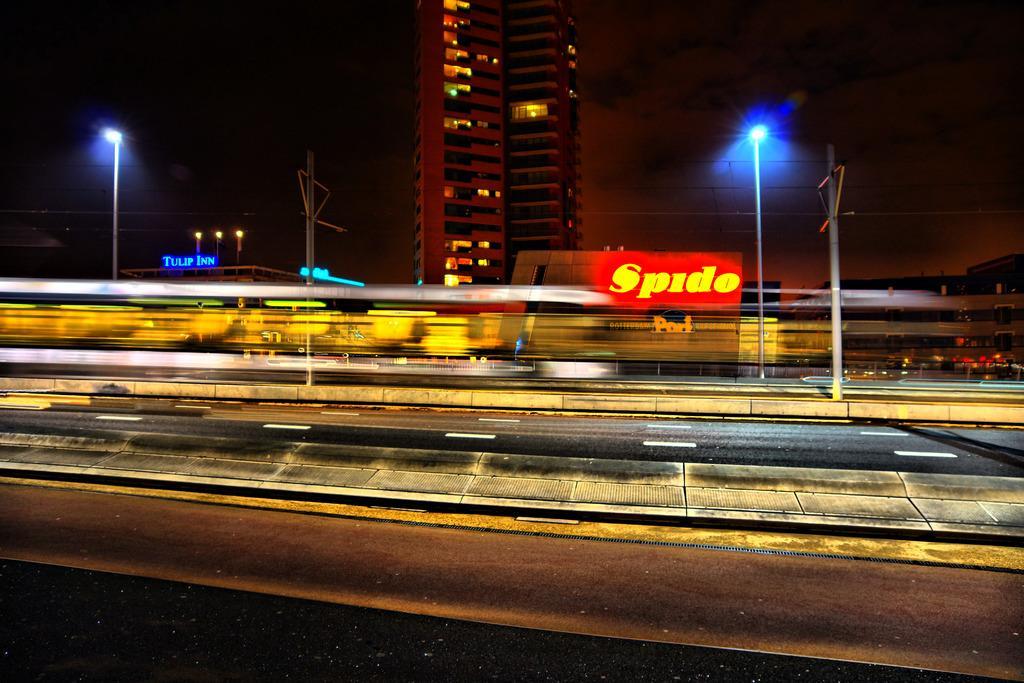In one or two sentences, can you explain what this image depicts? In this picture there are few buildings,street lights and wires. 